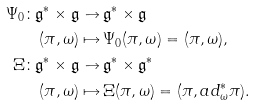<formula> <loc_0><loc_0><loc_500><loc_500>\Psi _ { 0 } \colon \mathfrak { g } ^ { * } \times \mathfrak { g } \to & \, \mathfrak { g } ^ { * } \times \mathfrak { g } \\ ( \pi , \omega ) \mapsto & \, \Psi _ { 0 } ( \pi , \omega ) = ( \pi , \omega ) , \\ \Xi \colon \mathfrak { g } ^ { * } \times \mathfrak { g } \to & \, \mathfrak { g } ^ { * } \times \mathfrak { g } ^ { * } \\ ( \pi , \omega ) \mapsto & \, \Xi ( \pi , \omega ) = ( \pi , a d ^ { * } _ { \omega } \pi ) .</formula> 